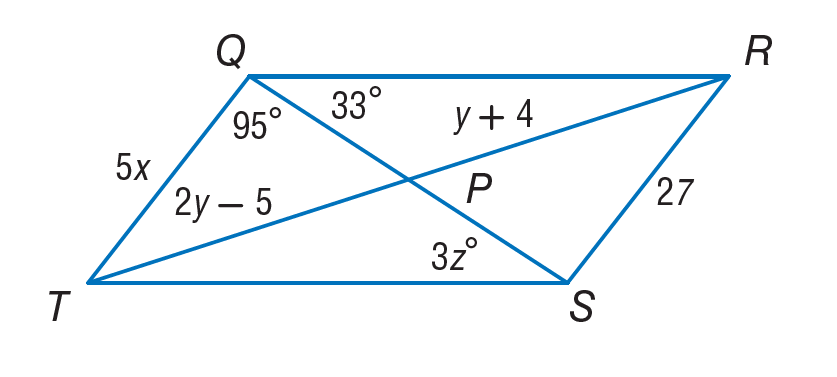Answer the mathemtical geometry problem and directly provide the correct option letter.
Question: If Q R S T is a parallelogram, find x.
Choices: A: 5.4 B: 9 C: 11 D: 13 A 